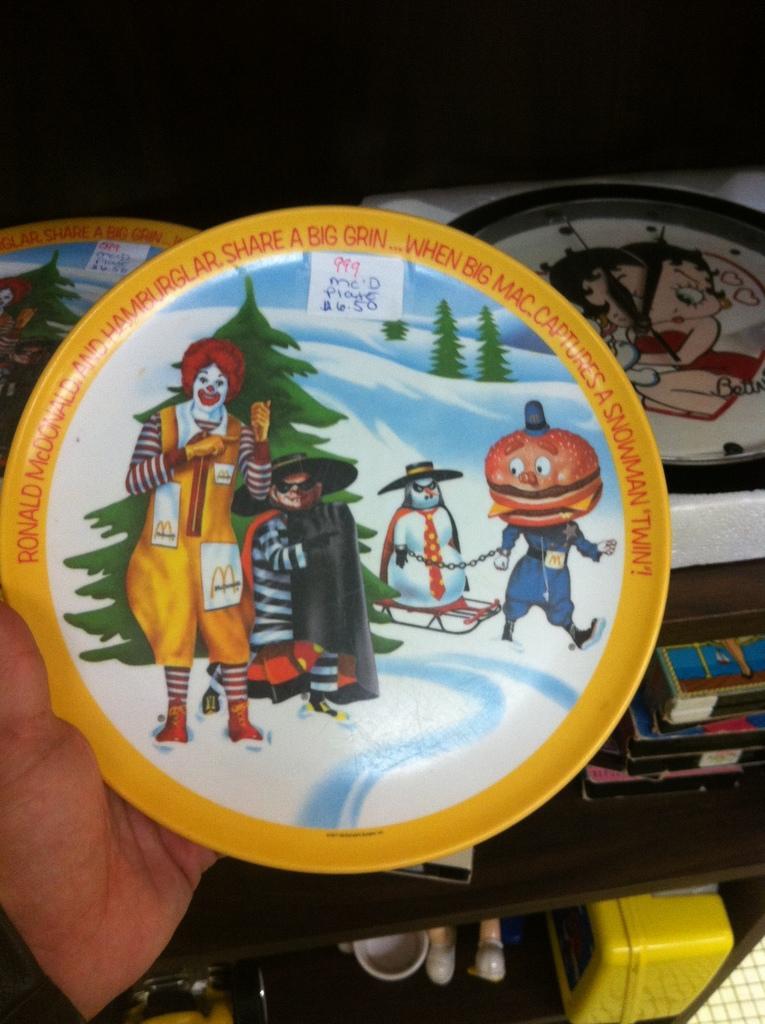Please provide a concise description of this image. In this image there is a plate with paintings on it is held in a person's hand, behind the plate there are a few other plates and some other objects on the wooden cupboard. 